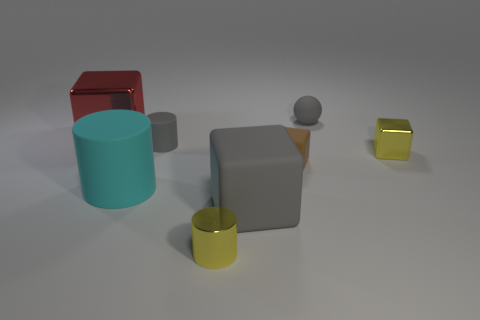What textures are visible on the objects in the image? The objects exhibit a variety of textures; the cylinders have a smooth and possibly reflective surface, the cube appears matte, and the small sphere on the cube has a slightly rough texture. 